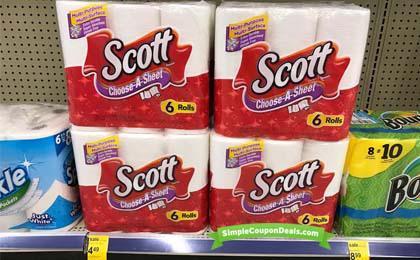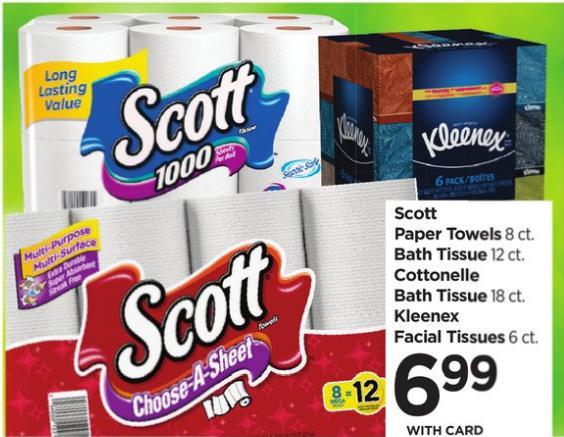The first image is the image on the left, the second image is the image on the right. Analyze the images presented: Is the assertion "At least one package is stacked on another in the image on the left." valid? Answer yes or no. Yes. The first image is the image on the left, the second image is the image on the right. For the images shown, is this caption "A multi-pack of paper towel rolls shows a woman in a red plaid shirt on the package front." true? Answer yes or no. No. 